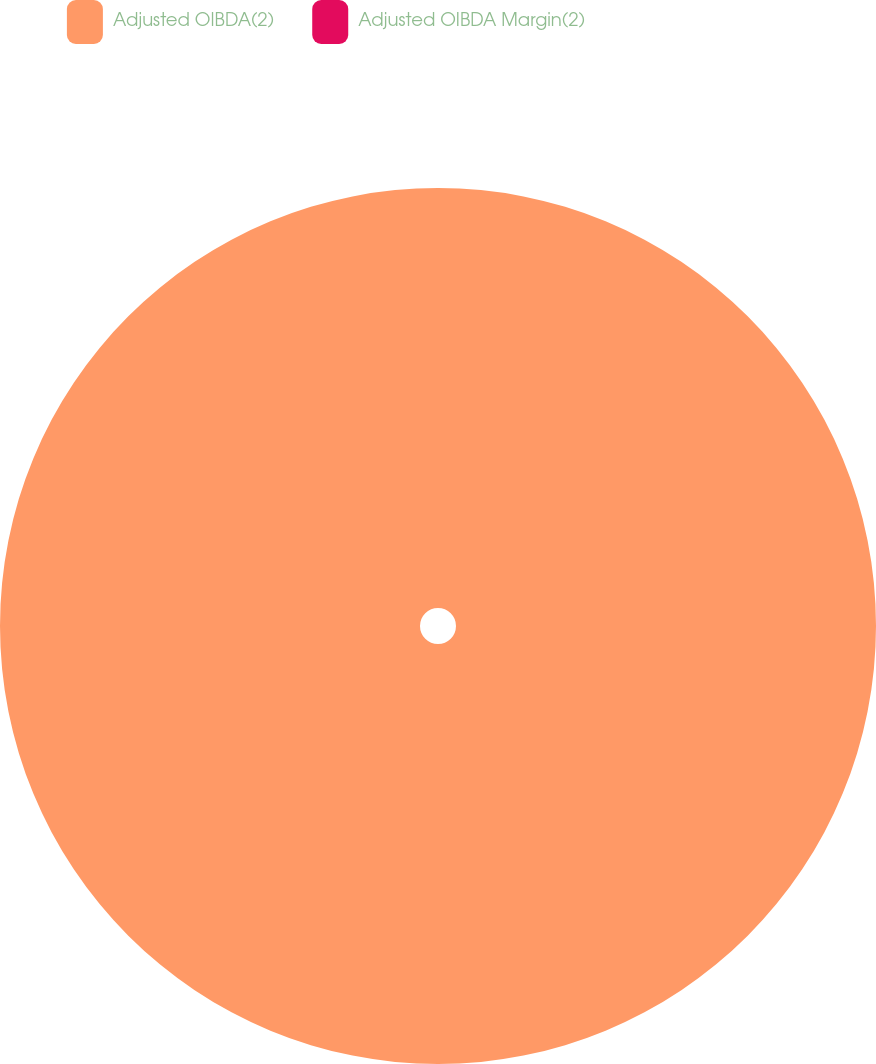Convert chart to OTSL. <chart><loc_0><loc_0><loc_500><loc_500><pie_chart><fcel>Adjusted OIBDA(2)<fcel>Adjusted OIBDA Margin(2)<nl><fcel>100.0%<fcel>0.0%<nl></chart> 